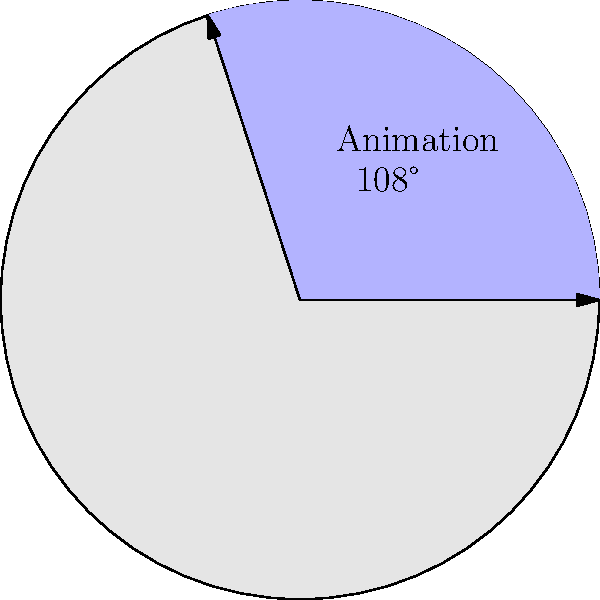In a pie chart representing the popularity of different film genres among stop-motion enthusiasts, the sector for "Animation" spans an angle of 108°. If the radius of the pie chart is 10 cm, what is the area of the sector representing Animation? Round your answer to the nearest square centimeter. To find the area of a sector in a circle, we can follow these steps:

1) The formula for the area of a sector is:

   $$A = \frac{\theta}{360°} \pi r^2$$

   Where $A$ is the area, $\theta$ is the central angle in degrees, and $r$ is the radius.

2) We're given:
   - $\theta = 108°$
   - $r = 10$ cm

3) Let's substitute these values into our formula:

   $$A = \frac{108°}{360°} \pi (10\text{ cm})^2$$

4) Simplify:
   $$A = \frac{3}{10} \pi (100\text{ cm}^2)$$
   $$A = 30\pi\text{ cm}^2$$

5) Calculate:
   $$A \approx 94.25\text{ cm}^2$$

6) Rounding to the nearest square centimeter:
   $$A \approx 94\text{ cm}^2$$
Answer: 94 cm² 